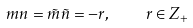<formula> <loc_0><loc_0><loc_500><loc_500>m n = \tilde { m } \tilde { n } = - r , \quad r \in Z _ { + }</formula> 